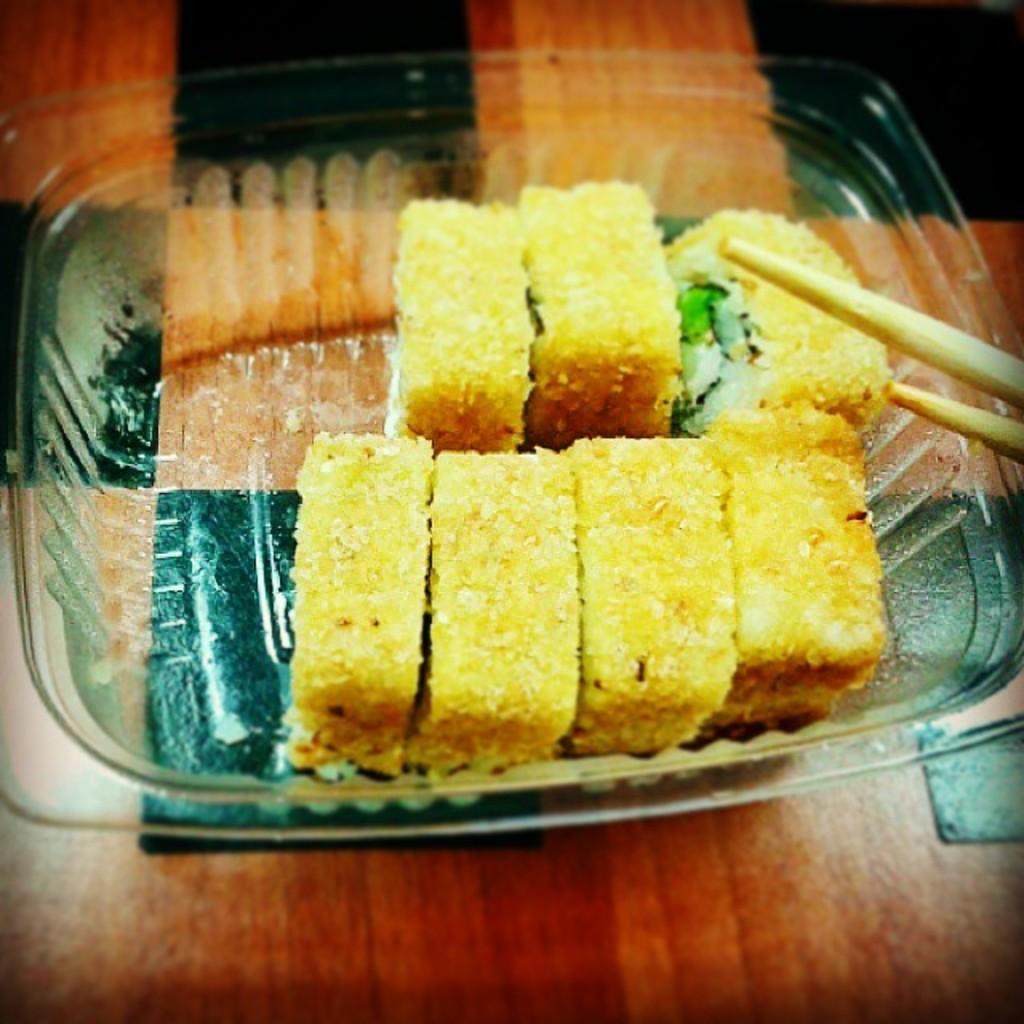How would you summarize this image in a sentence or two? In this picture we can see a bowl, there is some food present in the bowl, on the right side we can see chopsticks, at the bottom there is a wooden surface. 